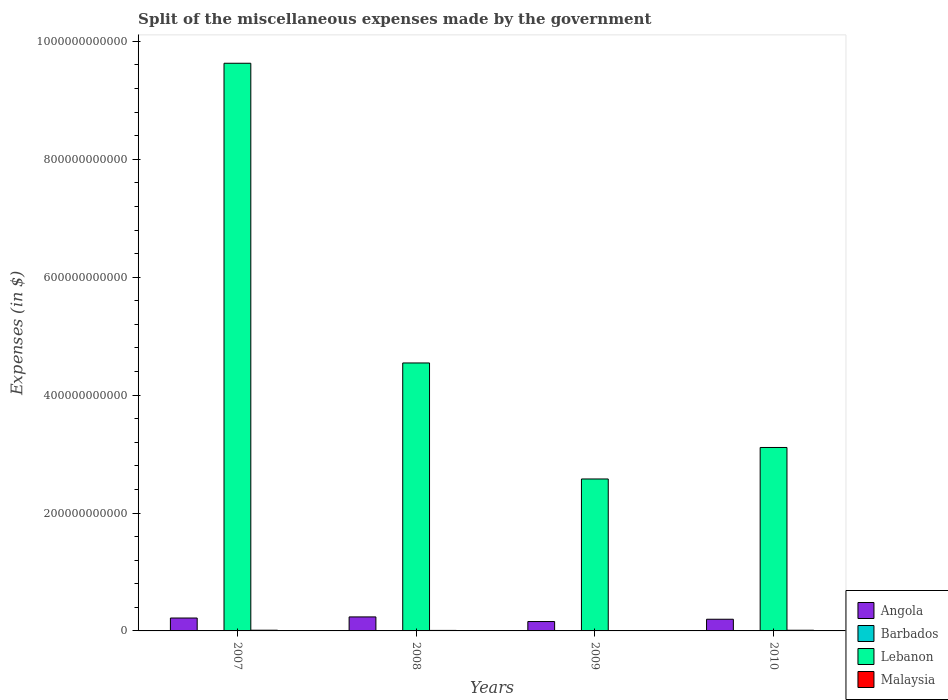How many groups of bars are there?
Offer a very short reply. 4. Are the number of bars per tick equal to the number of legend labels?
Ensure brevity in your answer.  Yes. Are the number of bars on each tick of the X-axis equal?
Make the answer very short. Yes. How many bars are there on the 2nd tick from the right?
Give a very brief answer. 4. What is the label of the 2nd group of bars from the left?
Provide a succinct answer. 2008. What is the miscellaneous expenses made by the government in Malaysia in 2010?
Provide a short and direct response. 1.15e+09. Across all years, what is the maximum miscellaneous expenses made by the government in Lebanon?
Offer a terse response. 9.63e+11. Across all years, what is the minimum miscellaneous expenses made by the government in Barbados?
Make the answer very short. 2.61e+07. In which year was the miscellaneous expenses made by the government in Lebanon maximum?
Offer a very short reply. 2007. In which year was the miscellaneous expenses made by the government in Angola minimum?
Provide a short and direct response. 2009. What is the total miscellaneous expenses made by the government in Angola in the graph?
Provide a short and direct response. 8.14e+1. What is the difference between the miscellaneous expenses made by the government in Barbados in 2008 and that in 2009?
Ensure brevity in your answer.  -5.27e+06. What is the difference between the miscellaneous expenses made by the government in Lebanon in 2008 and the miscellaneous expenses made by the government in Barbados in 2007?
Offer a terse response. 4.54e+11. What is the average miscellaneous expenses made by the government in Malaysia per year?
Provide a short and direct response. 9.72e+08. In the year 2007, what is the difference between the miscellaneous expenses made by the government in Angola and miscellaneous expenses made by the government in Barbados?
Offer a very short reply. 2.18e+1. What is the ratio of the miscellaneous expenses made by the government in Lebanon in 2007 to that in 2010?
Your answer should be very brief. 3.09. Is the miscellaneous expenses made by the government in Angola in 2008 less than that in 2010?
Your answer should be compact. No. Is the difference between the miscellaneous expenses made by the government in Angola in 2007 and 2008 greater than the difference between the miscellaneous expenses made by the government in Barbados in 2007 and 2008?
Your answer should be compact. No. What is the difference between the highest and the second highest miscellaneous expenses made by the government in Barbados?
Your answer should be compact. 2.02e+06. What is the difference between the highest and the lowest miscellaneous expenses made by the government in Barbados?
Keep it short and to the point. 2.66e+07. In how many years, is the miscellaneous expenses made by the government in Angola greater than the average miscellaneous expenses made by the government in Angola taken over all years?
Offer a very short reply. 2. What does the 4th bar from the left in 2009 represents?
Your response must be concise. Malaysia. What does the 3rd bar from the right in 2009 represents?
Offer a terse response. Barbados. Is it the case that in every year, the sum of the miscellaneous expenses made by the government in Angola and miscellaneous expenses made by the government in Malaysia is greater than the miscellaneous expenses made by the government in Lebanon?
Provide a short and direct response. No. How many bars are there?
Your answer should be very brief. 16. How many years are there in the graph?
Ensure brevity in your answer.  4. What is the difference between two consecutive major ticks on the Y-axis?
Give a very brief answer. 2.00e+11. Are the values on the major ticks of Y-axis written in scientific E-notation?
Offer a terse response. No. How many legend labels are there?
Your answer should be very brief. 4. What is the title of the graph?
Offer a very short reply. Split of the miscellaneous expenses made by the government. What is the label or title of the Y-axis?
Make the answer very short. Expenses (in $). What is the Expenses (in $) of Angola in 2007?
Offer a very short reply. 2.19e+1. What is the Expenses (in $) of Barbados in 2007?
Ensure brevity in your answer.  2.61e+07. What is the Expenses (in $) in Lebanon in 2007?
Offer a terse response. 9.63e+11. What is the Expenses (in $) of Malaysia in 2007?
Your response must be concise. 1.20e+09. What is the Expenses (in $) of Angola in 2008?
Your response must be concise. 2.38e+1. What is the Expenses (in $) of Barbados in 2008?
Your answer should be compact. 4.55e+07. What is the Expenses (in $) of Lebanon in 2008?
Your answer should be compact. 4.55e+11. What is the Expenses (in $) in Malaysia in 2008?
Give a very brief answer. 8.49e+08. What is the Expenses (in $) of Angola in 2009?
Provide a short and direct response. 1.59e+1. What is the Expenses (in $) of Barbados in 2009?
Ensure brevity in your answer.  5.07e+07. What is the Expenses (in $) of Lebanon in 2009?
Your response must be concise. 2.58e+11. What is the Expenses (in $) in Malaysia in 2009?
Offer a terse response. 6.85e+08. What is the Expenses (in $) in Angola in 2010?
Your answer should be very brief. 1.98e+1. What is the Expenses (in $) in Barbados in 2010?
Your response must be concise. 5.27e+07. What is the Expenses (in $) of Lebanon in 2010?
Provide a short and direct response. 3.11e+11. What is the Expenses (in $) of Malaysia in 2010?
Offer a very short reply. 1.15e+09. Across all years, what is the maximum Expenses (in $) in Angola?
Make the answer very short. 2.38e+1. Across all years, what is the maximum Expenses (in $) in Barbados?
Your response must be concise. 5.27e+07. Across all years, what is the maximum Expenses (in $) of Lebanon?
Provide a succinct answer. 9.63e+11. Across all years, what is the maximum Expenses (in $) in Malaysia?
Keep it short and to the point. 1.20e+09. Across all years, what is the minimum Expenses (in $) of Angola?
Provide a succinct answer. 1.59e+1. Across all years, what is the minimum Expenses (in $) in Barbados?
Make the answer very short. 2.61e+07. Across all years, what is the minimum Expenses (in $) of Lebanon?
Ensure brevity in your answer.  2.58e+11. Across all years, what is the minimum Expenses (in $) of Malaysia?
Keep it short and to the point. 6.85e+08. What is the total Expenses (in $) of Angola in the graph?
Give a very brief answer. 8.14e+1. What is the total Expenses (in $) of Barbados in the graph?
Make the answer very short. 1.75e+08. What is the total Expenses (in $) of Lebanon in the graph?
Keep it short and to the point. 1.99e+12. What is the total Expenses (in $) of Malaysia in the graph?
Ensure brevity in your answer.  3.89e+09. What is the difference between the Expenses (in $) in Angola in 2007 and that in 2008?
Your response must be concise. -1.88e+09. What is the difference between the Expenses (in $) of Barbados in 2007 and that in 2008?
Offer a terse response. -1.94e+07. What is the difference between the Expenses (in $) of Lebanon in 2007 and that in 2008?
Ensure brevity in your answer.  5.08e+11. What is the difference between the Expenses (in $) of Malaysia in 2007 and that in 2008?
Offer a terse response. 3.48e+08. What is the difference between the Expenses (in $) of Angola in 2007 and that in 2009?
Provide a succinct answer. 5.95e+09. What is the difference between the Expenses (in $) in Barbados in 2007 and that in 2009?
Your response must be concise. -2.46e+07. What is the difference between the Expenses (in $) of Lebanon in 2007 and that in 2009?
Provide a succinct answer. 7.05e+11. What is the difference between the Expenses (in $) in Malaysia in 2007 and that in 2009?
Give a very brief answer. 5.12e+08. What is the difference between the Expenses (in $) of Angola in 2007 and that in 2010?
Give a very brief answer. 2.07e+09. What is the difference between the Expenses (in $) in Barbados in 2007 and that in 2010?
Your answer should be very brief. -2.66e+07. What is the difference between the Expenses (in $) of Lebanon in 2007 and that in 2010?
Offer a very short reply. 6.52e+11. What is the difference between the Expenses (in $) in Malaysia in 2007 and that in 2010?
Your answer should be very brief. 4.26e+07. What is the difference between the Expenses (in $) of Angola in 2008 and that in 2009?
Your answer should be very brief. 7.83e+09. What is the difference between the Expenses (in $) in Barbados in 2008 and that in 2009?
Keep it short and to the point. -5.27e+06. What is the difference between the Expenses (in $) of Lebanon in 2008 and that in 2009?
Your answer should be very brief. 1.97e+11. What is the difference between the Expenses (in $) in Malaysia in 2008 and that in 2009?
Offer a terse response. 1.64e+08. What is the difference between the Expenses (in $) of Angola in 2008 and that in 2010?
Provide a short and direct response. 3.95e+09. What is the difference between the Expenses (in $) of Barbados in 2008 and that in 2010?
Provide a succinct answer. -7.29e+06. What is the difference between the Expenses (in $) in Lebanon in 2008 and that in 2010?
Provide a short and direct response. 1.43e+11. What is the difference between the Expenses (in $) in Malaysia in 2008 and that in 2010?
Your answer should be compact. -3.06e+08. What is the difference between the Expenses (in $) of Angola in 2009 and that in 2010?
Your answer should be compact. -3.88e+09. What is the difference between the Expenses (in $) in Barbados in 2009 and that in 2010?
Give a very brief answer. -2.02e+06. What is the difference between the Expenses (in $) of Lebanon in 2009 and that in 2010?
Keep it short and to the point. -5.34e+1. What is the difference between the Expenses (in $) in Malaysia in 2009 and that in 2010?
Your response must be concise. -4.70e+08. What is the difference between the Expenses (in $) in Angola in 2007 and the Expenses (in $) in Barbados in 2008?
Offer a very short reply. 2.18e+1. What is the difference between the Expenses (in $) in Angola in 2007 and the Expenses (in $) in Lebanon in 2008?
Offer a terse response. -4.33e+11. What is the difference between the Expenses (in $) in Angola in 2007 and the Expenses (in $) in Malaysia in 2008?
Your answer should be very brief. 2.10e+1. What is the difference between the Expenses (in $) of Barbados in 2007 and the Expenses (in $) of Lebanon in 2008?
Offer a terse response. -4.54e+11. What is the difference between the Expenses (in $) of Barbados in 2007 and the Expenses (in $) of Malaysia in 2008?
Keep it short and to the point. -8.23e+08. What is the difference between the Expenses (in $) in Lebanon in 2007 and the Expenses (in $) in Malaysia in 2008?
Your response must be concise. 9.62e+11. What is the difference between the Expenses (in $) in Angola in 2007 and the Expenses (in $) in Barbados in 2009?
Your response must be concise. 2.18e+1. What is the difference between the Expenses (in $) of Angola in 2007 and the Expenses (in $) of Lebanon in 2009?
Provide a short and direct response. -2.36e+11. What is the difference between the Expenses (in $) in Angola in 2007 and the Expenses (in $) in Malaysia in 2009?
Make the answer very short. 2.12e+1. What is the difference between the Expenses (in $) of Barbados in 2007 and the Expenses (in $) of Lebanon in 2009?
Make the answer very short. -2.58e+11. What is the difference between the Expenses (in $) of Barbados in 2007 and the Expenses (in $) of Malaysia in 2009?
Ensure brevity in your answer.  -6.59e+08. What is the difference between the Expenses (in $) in Lebanon in 2007 and the Expenses (in $) in Malaysia in 2009?
Give a very brief answer. 9.62e+11. What is the difference between the Expenses (in $) in Angola in 2007 and the Expenses (in $) in Barbados in 2010?
Offer a very short reply. 2.18e+1. What is the difference between the Expenses (in $) of Angola in 2007 and the Expenses (in $) of Lebanon in 2010?
Give a very brief answer. -2.89e+11. What is the difference between the Expenses (in $) of Angola in 2007 and the Expenses (in $) of Malaysia in 2010?
Offer a terse response. 2.07e+1. What is the difference between the Expenses (in $) of Barbados in 2007 and the Expenses (in $) of Lebanon in 2010?
Keep it short and to the point. -3.11e+11. What is the difference between the Expenses (in $) of Barbados in 2007 and the Expenses (in $) of Malaysia in 2010?
Your response must be concise. -1.13e+09. What is the difference between the Expenses (in $) of Lebanon in 2007 and the Expenses (in $) of Malaysia in 2010?
Make the answer very short. 9.62e+11. What is the difference between the Expenses (in $) in Angola in 2008 and the Expenses (in $) in Barbados in 2009?
Give a very brief answer. 2.37e+1. What is the difference between the Expenses (in $) of Angola in 2008 and the Expenses (in $) of Lebanon in 2009?
Your answer should be very brief. -2.34e+11. What is the difference between the Expenses (in $) in Angola in 2008 and the Expenses (in $) in Malaysia in 2009?
Give a very brief answer. 2.31e+1. What is the difference between the Expenses (in $) in Barbados in 2008 and the Expenses (in $) in Lebanon in 2009?
Keep it short and to the point. -2.58e+11. What is the difference between the Expenses (in $) in Barbados in 2008 and the Expenses (in $) in Malaysia in 2009?
Offer a very short reply. -6.40e+08. What is the difference between the Expenses (in $) in Lebanon in 2008 and the Expenses (in $) in Malaysia in 2009?
Your answer should be compact. 4.54e+11. What is the difference between the Expenses (in $) of Angola in 2008 and the Expenses (in $) of Barbados in 2010?
Provide a short and direct response. 2.37e+1. What is the difference between the Expenses (in $) of Angola in 2008 and the Expenses (in $) of Lebanon in 2010?
Your answer should be very brief. -2.87e+11. What is the difference between the Expenses (in $) in Angola in 2008 and the Expenses (in $) in Malaysia in 2010?
Make the answer very short. 2.26e+1. What is the difference between the Expenses (in $) of Barbados in 2008 and the Expenses (in $) of Lebanon in 2010?
Make the answer very short. -3.11e+11. What is the difference between the Expenses (in $) in Barbados in 2008 and the Expenses (in $) in Malaysia in 2010?
Give a very brief answer. -1.11e+09. What is the difference between the Expenses (in $) of Lebanon in 2008 and the Expenses (in $) of Malaysia in 2010?
Provide a succinct answer. 4.53e+11. What is the difference between the Expenses (in $) in Angola in 2009 and the Expenses (in $) in Barbados in 2010?
Your answer should be very brief. 1.59e+1. What is the difference between the Expenses (in $) in Angola in 2009 and the Expenses (in $) in Lebanon in 2010?
Your answer should be very brief. -2.95e+11. What is the difference between the Expenses (in $) in Angola in 2009 and the Expenses (in $) in Malaysia in 2010?
Your response must be concise. 1.48e+1. What is the difference between the Expenses (in $) of Barbados in 2009 and the Expenses (in $) of Lebanon in 2010?
Provide a short and direct response. -3.11e+11. What is the difference between the Expenses (in $) in Barbados in 2009 and the Expenses (in $) in Malaysia in 2010?
Give a very brief answer. -1.10e+09. What is the difference between the Expenses (in $) in Lebanon in 2009 and the Expenses (in $) in Malaysia in 2010?
Give a very brief answer. 2.57e+11. What is the average Expenses (in $) of Angola per year?
Your response must be concise. 2.03e+1. What is the average Expenses (in $) in Barbados per year?
Offer a terse response. 4.38e+07. What is the average Expenses (in $) in Lebanon per year?
Your answer should be compact. 4.97e+11. What is the average Expenses (in $) of Malaysia per year?
Give a very brief answer. 9.72e+08. In the year 2007, what is the difference between the Expenses (in $) of Angola and Expenses (in $) of Barbados?
Make the answer very short. 2.18e+1. In the year 2007, what is the difference between the Expenses (in $) in Angola and Expenses (in $) in Lebanon?
Give a very brief answer. -9.41e+11. In the year 2007, what is the difference between the Expenses (in $) in Angola and Expenses (in $) in Malaysia?
Make the answer very short. 2.07e+1. In the year 2007, what is the difference between the Expenses (in $) in Barbados and Expenses (in $) in Lebanon?
Offer a terse response. -9.63e+11. In the year 2007, what is the difference between the Expenses (in $) of Barbados and Expenses (in $) of Malaysia?
Give a very brief answer. -1.17e+09. In the year 2007, what is the difference between the Expenses (in $) of Lebanon and Expenses (in $) of Malaysia?
Your answer should be very brief. 9.62e+11. In the year 2008, what is the difference between the Expenses (in $) in Angola and Expenses (in $) in Barbados?
Offer a terse response. 2.37e+1. In the year 2008, what is the difference between the Expenses (in $) of Angola and Expenses (in $) of Lebanon?
Provide a succinct answer. -4.31e+11. In the year 2008, what is the difference between the Expenses (in $) of Angola and Expenses (in $) of Malaysia?
Offer a very short reply. 2.29e+1. In the year 2008, what is the difference between the Expenses (in $) of Barbados and Expenses (in $) of Lebanon?
Provide a short and direct response. -4.54e+11. In the year 2008, what is the difference between the Expenses (in $) of Barbados and Expenses (in $) of Malaysia?
Your response must be concise. -8.04e+08. In the year 2008, what is the difference between the Expenses (in $) in Lebanon and Expenses (in $) in Malaysia?
Make the answer very short. 4.54e+11. In the year 2009, what is the difference between the Expenses (in $) of Angola and Expenses (in $) of Barbados?
Offer a terse response. 1.59e+1. In the year 2009, what is the difference between the Expenses (in $) in Angola and Expenses (in $) in Lebanon?
Keep it short and to the point. -2.42e+11. In the year 2009, what is the difference between the Expenses (in $) in Angola and Expenses (in $) in Malaysia?
Your answer should be compact. 1.52e+1. In the year 2009, what is the difference between the Expenses (in $) in Barbados and Expenses (in $) in Lebanon?
Provide a succinct answer. -2.58e+11. In the year 2009, what is the difference between the Expenses (in $) in Barbados and Expenses (in $) in Malaysia?
Make the answer very short. -6.34e+08. In the year 2009, what is the difference between the Expenses (in $) in Lebanon and Expenses (in $) in Malaysia?
Your response must be concise. 2.57e+11. In the year 2010, what is the difference between the Expenses (in $) of Angola and Expenses (in $) of Barbados?
Offer a very short reply. 1.98e+1. In the year 2010, what is the difference between the Expenses (in $) of Angola and Expenses (in $) of Lebanon?
Your answer should be very brief. -2.91e+11. In the year 2010, what is the difference between the Expenses (in $) of Angola and Expenses (in $) of Malaysia?
Provide a succinct answer. 1.86e+1. In the year 2010, what is the difference between the Expenses (in $) in Barbados and Expenses (in $) in Lebanon?
Ensure brevity in your answer.  -3.11e+11. In the year 2010, what is the difference between the Expenses (in $) in Barbados and Expenses (in $) in Malaysia?
Your answer should be very brief. -1.10e+09. In the year 2010, what is the difference between the Expenses (in $) in Lebanon and Expenses (in $) in Malaysia?
Keep it short and to the point. 3.10e+11. What is the ratio of the Expenses (in $) of Angola in 2007 to that in 2008?
Offer a very short reply. 0.92. What is the ratio of the Expenses (in $) in Barbados in 2007 to that in 2008?
Offer a very short reply. 0.57. What is the ratio of the Expenses (in $) of Lebanon in 2007 to that in 2008?
Offer a very short reply. 2.12. What is the ratio of the Expenses (in $) of Malaysia in 2007 to that in 2008?
Your answer should be very brief. 1.41. What is the ratio of the Expenses (in $) of Angola in 2007 to that in 2009?
Offer a terse response. 1.37. What is the ratio of the Expenses (in $) in Barbados in 2007 to that in 2009?
Offer a terse response. 0.51. What is the ratio of the Expenses (in $) of Lebanon in 2007 to that in 2009?
Give a very brief answer. 3.74. What is the ratio of the Expenses (in $) of Malaysia in 2007 to that in 2009?
Make the answer very short. 1.75. What is the ratio of the Expenses (in $) of Angola in 2007 to that in 2010?
Offer a terse response. 1.1. What is the ratio of the Expenses (in $) in Barbados in 2007 to that in 2010?
Keep it short and to the point. 0.49. What is the ratio of the Expenses (in $) of Lebanon in 2007 to that in 2010?
Make the answer very short. 3.09. What is the ratio of the Expenses (in $) of Malaysia in 2007 to that in 2010?
Give a very brief answer. 1.04. What is the ratio of the Expenses (in $) of Angola in 2008 to that in 2009?
Keep it short and to the point. 1.49. What is the ratio of the Expenses (in $) in Barbados in 2008 to that in 2009?
Your response must be concise. 0.9. What is the ratio of the Expenses (in $) of Lebanon in 2008 to that in 2009?
Provide a succinct answer. 1.76. What is the ratio of the Expenses (in $) of Malaysia in 2008 to that in 2009?
Keep it short and to the point. 1.24. What is the ratio of the Expenses (in $) of Angola in 2008 to that in 2010?
Your answer should be very brief. 1.2. What is the ratio of the Expenses (in $) of Barbados in 2008 to that in 2010?
Give a very brief answer. 0.86. What is the ratio of the Expenses (in $) of Lebanon in 2008 to that in 2010?
Give a very brief answer. 1.46. What is the ratio of the Expenses (in $) of Malaysia in 2008 to that in 2010?
Provide a succinct answer. 0.74. What is the ratio of the Expenses (in $) in Angola in 2009 to that in 2010?
Your answer should be compact. 0.8. What is the ratio of the Expenses (in $) of Barbados in 2009 to that in 2010?
Make the answer very short. 0.96. What is the ratio of the Expenses (in $) of Lebanon in 2009 to that in 2010?
Offer a terse response. 0.83. What is the ratio of the Expenses (in $) of Malaysia in 2009 to that in 2010?
Ensure brevity in your answer.  0.59. What is the difference between the highest and the second highest Expenses (in $) in Angola?
Your answer should be very brief. 1.88e+09. What is the difference between the highest and the second highest Expenses (in $) of Barbados?
Make the answer very short. 2.02e+06. What is the difference between the highest and the second highest Expenses (in $) in Lebanon?
Offer a very short reply. 5.08e+11. What is the difference between the highest and the second highest Expenses (in $) of Malaysia?
Offer a terse response. 4.26e+07. What is the difference between the highest and the lowest Expenses (in $) in Angola?
Offer a terse response. 7.83e+09. What is the difference between the highest and the lowest Expenses (in $) of Barbados?
Make the answer very short. 2.66e+07. What is the difference between the highest and the lowest Expenses (in $) in Lebanon?
Offer a very short reply. 7.05e+11. What is the difference between the highest and the lowest Expenses (in $) of Malaysia?
Your response must be concise. 5.12e+08. 